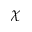Convert formula to latex. <formula><loc_0><loc_0><loc_500><loc_500>\chi</formula> 